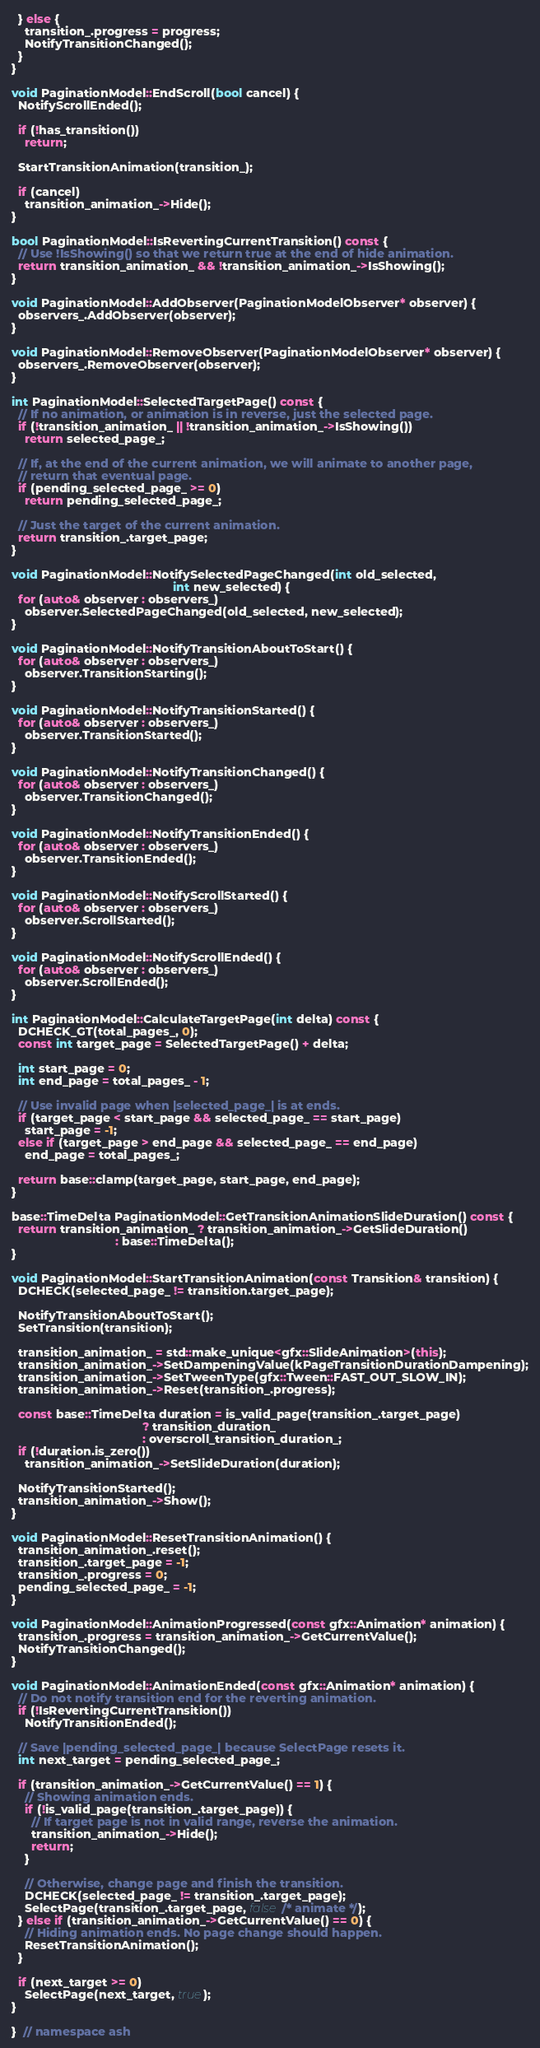Convert code to text. <code><loc_0><loc_0><loc_500><loc_500><_C++_>  } else {
    transition_.progress = progress;
    NotifyTransitionChanged();
  }
}

void PaginationModel::EndScroll(bool cancel) {
  NotifyScrollEnded();

  if (!has_transition())
    return;

  StartTransitionAnimation(transition_);

  if (cancel)
    transition_animation_->Hide();
}

bool PaginationModel::IsRevertingCurrentTransition() const {
  // Use !IsShowing() so that we return true at the end of hide animation.
  return transition_animation_ && !transition_animation_->IsShowing();
}

void PaginationModel::AddObserver(PaginationModelObserver* observer) {
  observers_.AddObserver(observer);
}

void PaginationModel::RemoveObserver(PaginationModelObserver* observer) {
  observers_.RemoveObserver(observer);
}

int PaginationModel::SelectedTargetPage() const {
  // If no animation, or animation is in reverse, just the selected page.
  if (!transition_animation_ || !transition_animation_->IsShowing())
    return selected_page_;

  // If, at the end of the current animation, we will animate to another page,
  // return that eventual page.
  if (pending_selected_page_ >= 0)
    return pending_selected_page_;

  // Just the target of the current animation.
  return transition_.target_page;
}

void PaginationModel::NotifySelectedPageChanged(int old_selected,
                                                int new_selected) {
  for (auto& observer : observers_)
    observer.SelectedPageChanged(old_selected, new_selected);
}

void PaginationModel::NotifyTransitionAboutToStart() {
  for (auto& observer : observers_)
    observer.TransitionStarting();
}

void PaginationModel::NotifyTransitionStarted() {
  for (auto& observer : observers_)
    observer.TransitionStarted();
}

void PaginationModel::NotifyTransitionChanged() {
  for (auto& observer : observers_)
    observer.TransitionChanged();
}

void PaginationModel::NotifyTransitionEnded() {
  for (auto& observer : observers_)
    observer.TransitionEnded();
}

void PaginationModel::NotifyScrollStarted() {
  for (auto& observer : observers_)
    observer.ScrollStarted();
}

void PaginationModel::NotifyScrollEnded() {
  for (auto& observer : observers_)
    observer.ScrollEnded();
}

int PaginationModel::CalculateTargetPage(int delta) const {
  DCHECK_GT(total_pages_, 0);
  const int target_page = SelectedTargetPage() + delta;

  int start_page = 0;
  int end_page = total_pages_ - 1;

  // Use invalid page when |selected_page_| is at ends.
  if (target_page < start_page && selected_page_ == start_page)
    start_page = -1;
  else if (target_page > end_page && selected_page_ == end_page)
    end_page = total_pages_;

  return base::clamp(target_page, start_page, end_page);
}

base::TimeDelta PaginationModel::GetTransitionAnimationSlideDuration() const {
  return transition_animation_ ? transition_animation_->GetSlideDuration()
                               : base::TimeDelta();
}

void PaginationModel::StartTransitionAnimation(const Transition& transition) {
  DCHECK(selected_page_ != transition.target_page);

  NotifyTransitionAboutToStart();
  SetTransition(transition);

  transition_animation_ = std::make_unique<gfx::SlideAnimation>(this);
  transition_animation_->SetDampeningValue(kPageTransitionDurationDampening);
  transition_animation_->SetTweenType(gfx::Tween::FAST_OUT_SLOW_IN);
  transition_animation_->Reset(transition_.progress);

  const base::TimeDelta duration = is_valid_page(transition_.target_page)
                                       ? transition_duration_
                                       : overscroll_transition_duration_;
  if (!duration.is_zero())
    transition_animation_->SetSlideDuration(duration);

  NotifyTransitionStarted();
  transition_animation_->Show();
}

void PaginationModel::ResetTransitionAnimation() {
  transition_animation_.reset();
  transition_.target_page = -1;
  transition_.progress = 0;
  pending_selected_page_ = -1;
}

void PaginationModel::AnimationProgressed(const gfx::Animation* animation) {
  transition_.progress = transition_animation_->GetCurrentValue();
  NotifyTransitionChanged();
}

void PaginationModel::AnimationEnded(const gfx::Animation* animation) {
  // Do not notify transition end for the reverting animation.
  if (!IsRevertingCurrentTransition())
    NotifyTransitionEnded();

  // Save |pending_selected_page_| because SelectPage resets it.
  int next_target = pending_selected_page_;

  if (transition_animation_->GetCurrentValue() == 1) {
    // Showing animation ends.
    if (!is_valid_page(transition_.target_page)) {
      // If target page is not in valid range, reverse the animation.
      transition_animation_->Hide();
      return;
    }

    // Otherwise, change page and finish the transition.
    DCHECK(selected_page_ != transition_.target_page);
    SelectPage(transition_.target_page, false /* animate */);
  } else if (transition_animation_->GetCurrentValue() == 0) {
    // Hiding animation ends. No page change should happen.
    ResetTransitionAnimation();
  }

  if (next_target >= 0)
    SelectPage(next_target, true);
}

}  // namespace ash
</code> 